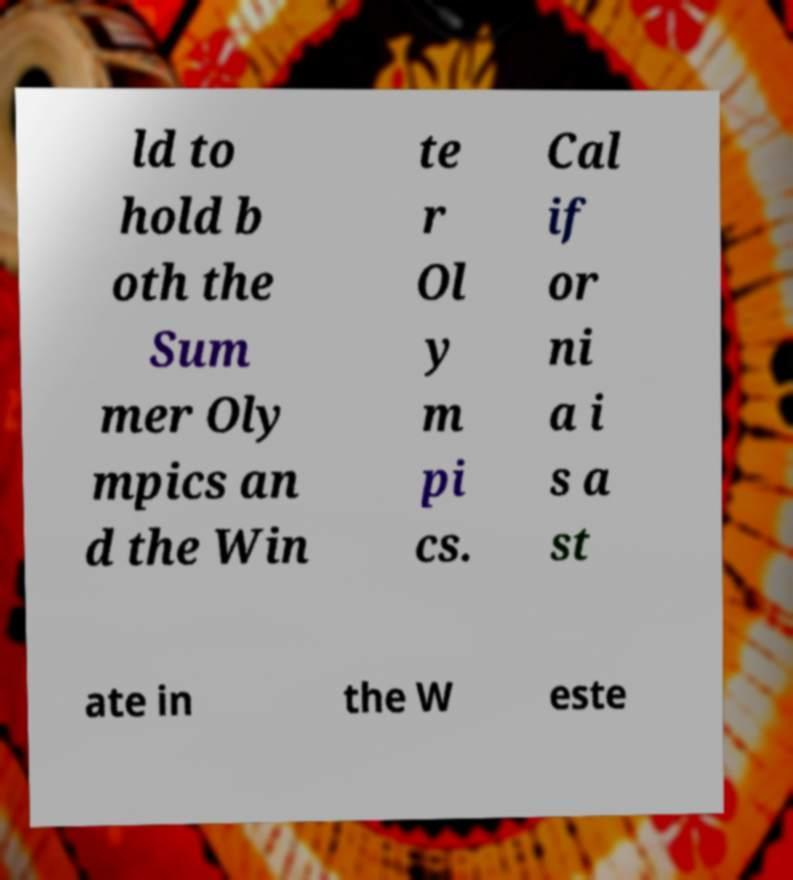Can you read and provide the text displayed in the image?This photo seems to have some interesting text. Can you extract and type it out for me? ld to hold b oth the Sum mer Oly mpics an d the Win te r Ol y m pi cs. Cal if or ni a i s a st ate in the W este 